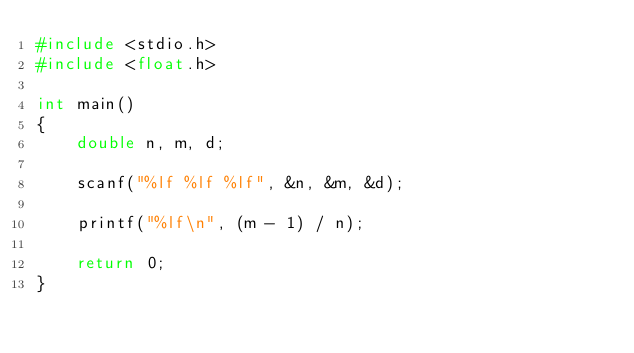<code> <loc_0><loc_0><loc_500><loc_500><_C_>#include <stdio.h>
#include <float.h>

int main()
{
	double n, m, d;

	scanf("%lf %lf %lf", &n, &m, &d);

	printf("%lf\n", (m - 1) / n);

	return 0;
}
</code> 